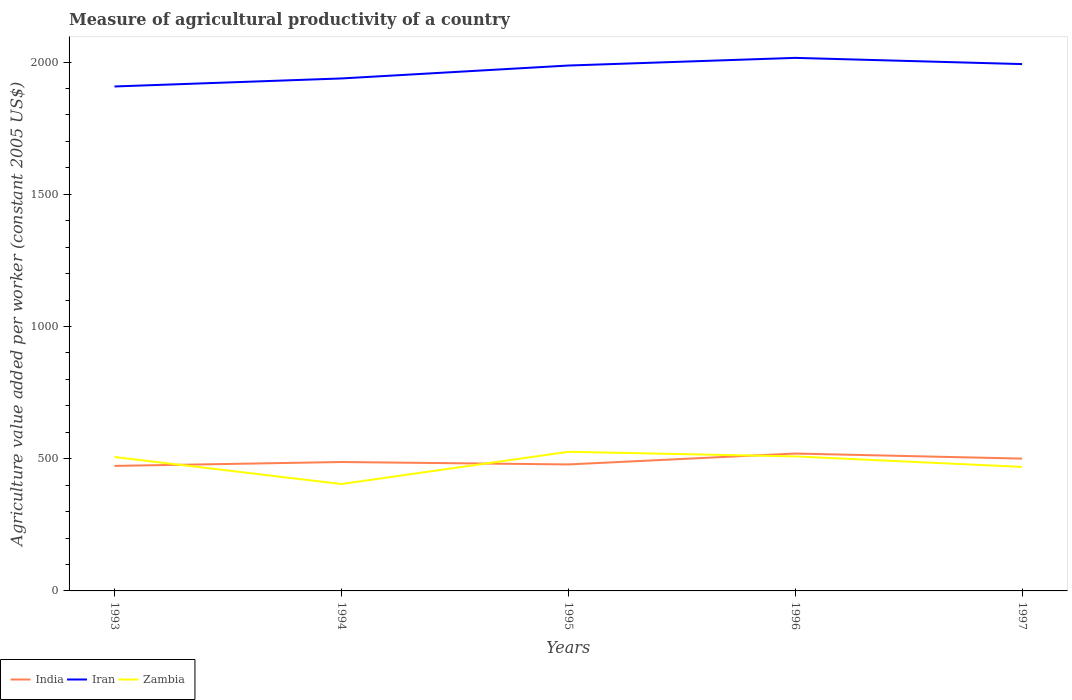Is the number of lines equal to the number of legend labels?
Offer a very short reply. Yes. Across all years, what is the maximum measure of agricultural productivity in Iran?
Offer a very short reply. 1907.84. In which year was the measure of agricultural productivity in Iran maximum?
Offer a very short reply. 1993. What is the total measure of agricultural productivity in India in the graph?
Offer a terse response. -32.1. What is the difference between the highest and the second highest measure of agricultural productivity in Iran?
Provide a succinct answer. 108.12. Is the measure of agricultural productivity in India strictly greater than the measure of agricultural productivity in Zambia over the years?
Make the answer very short. No. Where does the legend appear in the graph?
Keep it short and to the point. Bottom left. How many legend labels are there?
Offer a very short reply. 3. How are the legend labels stacked?
Keep it short and to the point. Horizontal. What is the title of the graph?
Your answer should be compact. Measure of agricultural productivity of a country. Does "Central African Republic" appear as one of the legend labels in the graph?
Your response must be concise. No. What is the label or title of the Y-axis?
Offer a terse response. Agriculture value added per worker (constant 2005 US$). What is the Agriculture value added per worker (constant 2005 US$) of India in 1993?
Your response must be concise. 472.8. What is the Agriculture value added per worker (constant 2005 US$) in Iran in 1993?
Provide a short and direct response. 1907.84. What is the Agriculture value added per worker (constant 2005 US$) in Zambia in 1993?
Keep it short and to the point. 506.52. What is the Agriculture value added per worker (constant 2005 US$) in India in 1994?
Your answer should be very brief. 487.5. What is the Agriculture value added per worker (constant 2005 US$) of Iran in 1994?
Provide a succinct answer. 1938.18. What is the Agriculture value added per worker (constant 2005 US$) of Zambia in 1994?
Ensure brevity in your answer.  404.28. What is the Agriculture value added per worker (constant 2005 US$) of India in 1995?
Provide a short and direct response. 478.37. What is the Agriculture value added per worker (constant 2005 US$) of Iran in 1995?
Your response must be concise. 1987.03. What is the Agriculture value added per worker (constant 2005 US$) in Zambia in 1995?
Your answer should be very brief. 526.2. What is the Agriculture value added per worker (constant 2005 US$) of India in 1996?
Your response must be concise. 519.6. What is the Agriculture value added per worker (constant 2005 US$) in Iran in 1996?
Offer a terse response. 2015.96. What is the Agriculture value added per worker (constant 2005 US$) of Zambia in 1996?
Your response must be concise. 508.75. What is the Agriculture value added per worker (constant 2005 US$) in India in 1997?
Your response must be concise. 500.38. What is the Agriculture value added per worker (constant 2005 US$) in Iran in 1997?
Your answer should be very brief. 1992.49. What is the Agriculture value added per worker (constant 2005 US$) in Zambia in 1997?
Your response must be concise. 469.04. Across all years, what is the maximum Agriculture value added per worker (constant 2005 US$) of India?
Your answer should be compact. 519.6. Across all years, what is the maximum Agriculture value added per worker (constant 2005 US$) in Iran?
Make the answer very short. 2015.96. Across all years, what is the maximum Agriculture value added per worker (constant 2005 US$) in Zambia?
Make the answer very short. 526.2. Across all years, what is the minimum Agriculture value added per worker (constant 2005 US$) in India?
Ensure brevity in your answer.  472.8. Across all years, what is the minimum Agriculture value added per worker (constant 2005 US$) in Iran?
Give a very brief answer. 1907.84. Across all years, what is the minimum Agriculture value added per worker (constant 2005 US$) of Zambia?
Provide a succinct answer. 404.28. What is the total Agriculture value added per worker (constant 2005 US$) in India in the graph?
Offer a terse response. 2458.64. What is the total Agriculture value added per worker (constant 2005 US$) in Iran in the graph?
Give a very brief answer. 9841.49. What is the total Agriculture value added per worker (constant 2005 US$) of Zambia in the graph?
Provide a short and direct response. 2414.79. What is the difference between the Agriculture value added per worker (constant 2005 US$) in India in 1993 and that in 1994?
Provide a short and direct response. -14.7. What is the difference between the Agriculture value added per worker (constant 2005 US$) of Iran in 1993 and that in 1994?
Make the answer very short. -30.34. What is the difference between the Agriculture value added per worker (constant 2005 US$) of Zambia in 1993 and that in 1994?
Provide a short and direct response. 102.23. What is the difference between the Agriculture value added per worker (constant 2005 US$) in India in 1993 and that in 1995?
Ensure brevity in your answer.  -5.57. What is the difference between the Agriculture value added per worker (constant 2005 US$) in Iran in 1993 and that in 1995?
Offer a terse response. -79.19. What is the difference between the Agriculture value added per worker (constant 2005 US$) in Zambia in 1993 and that in 1995?
Make the answer very short. -19.68. What is the difference between the Agriculture value added per worker (constant 2005 US$) in India in 1993 and that in 1996?
Give a very brief answer. -46.8. What is the difference between the Agriculture value added per worker (constant 2005 US$) in Iran in 1993 and that in 1996?
Your answer should be compact. -108.12. What is the difference between the Agriculture value added per worker (constant 2005 US$) of Zambia in 1993 and that in 1996?
Your answer should be very brief. -2.24. What is the difference between the Agriculture value added per worker (constant 2005 US$) in India in 1993 and that in 1997?
Keep it short and to the point. -27.58. What is the difference between the Agriculture value added per worker (constant 2005 US$) in Iran in 1993 and that in 1997?
Give a very brief answer. -84.65. What is the difference between the Agriculture value added per worker (constant 2005 US$) of Zambia in 1993 and that in 1997?
Ensure brevity in your answer.  37.48. What is the difference between the Agriculture value added per worker (constant 2005 US$) in India in 1994 and that in 1995?
Ensure brevity in your answer.  9.13. What is the difference between the Agriculture value added per worker (constant 2005 US$) in Iran in 1994 and that in 1995?
Your answer should be compact. -48.85. What is the difference between the Agriculture value added per worker (constant 2005 US$) of Zambia in 1994 and that in 1995?
Make the answer very short. -121.91. What is the difference between the Agriculture value added per worker (constant 2005 US$) of India in 1994 and that in 1996?
Your response must be concise. -32.1. What is the difference between the Agriculture value added per worker (constant 2005 US$) of Iran in 1994 and that in 1996?
Your response must be concise. -77.78. What is the difference between the Agriculture value added per worker (constant 2005 US$) in Zambia in 1994 and that in 1996?
Your answer should be very brief. -104.47. What is the difference between the Agriculture value added per worker (constant 2005 US$) of India in 1994 and that in 1997?
Provide a succinct answer. -12.88. What is the difference between the Agriculture value added per worker (constant 2005 US$) in Iran in 1994 and that in 1997?
Give a very brief answer. -54.31. What is the difference between the Agriculture value added per worker (constant 2005 US$) of Zambia in 1994 and that in 1997?
Offer a terse response. -64.76. What is the difference between the Agriculture value added per worker (constant 2005 US$) of India in 1995 and that in 1996?
Give a very brief answer. -41.23. What is the difference between the Agriculture value added per worker (constant 2005 US$) in Iran in 1995 and that in 1996?
Provide a short and direct response. -28.93. What is the difference between the Agriculture value added per worker (constant 2005 US$) of Zambia in 1995 and that in 1996?
Give a very brief answer. 17.44. What is the difference between the Agriculture value added per worker (constant 2005 US$) in India in 1995 and that in 1997?
Make the answer very short. -22.01. What is the difference between the Agriculture value added per worker (constant 2005 US$) of Iran in 1995 and that in 1997?
Your answer should be very brief. -5.46. What is the difference between the Agriculture value added per worker (constant 2005 US$) of Zambia in 1995 and that in 1997?
Keep it short and to the point. 57.15. What is the difference between the Agriculture value added per worker (constant 2005 US$) in India in 1996 and that in 1997?
Your response must be concise. 19.22. What is the difference between the Agriculture value added per worker (constant 2005 US$) of Iran in 1996 and that in 1997?
Provide a short and direct response. 23.47. What is the difference between the Agriculture value added per worker (constant 2005 US$) of Zambia in 1996 and that in 1997?
Give a very brief answer. 39.71. What is the difference between the Agriculture value added per worker (constant 2005 US$) of India in 1993 and the Agriculture value added per worker (constant 2005 US$) of Iran in 1994?
Your answer should be compact. -1465.38. What is the difference between the Agriculture value added per worker (constant 2005 US$) of India in 1993 and the Agriculture value added per worker (constant 2005 US$) of Zambia in 1994?
Your answer should be very brief. 68.51. What is the difference between the Agriculture value added per worker (constant 2005 US$) in Iran in 1993 and the Agriculture value added per worker (constant 2005 US$) in Zambia in 1994?
Make the answer very short. 1503.56. What is the difference between the Agriculture value added per worker (constant 2005 US$) of India in 1993 and the Agriculture value added per worker (constant 2005 US$) of Iran in 1995?
Provide a succinct answer. -1514.23. What is the difference between the Agriculture value added per worker (constant 2005 US$) of India in 1993 and the Agriculture value added per worker (constant 2005 US$) of Zambia in 1995?
Provide a short and direct response. -53.4. What is the difference between the Agriculture value added per worker (constant 2005 US$) in Iran in 1993 and the Agriculture value added per worker (constant 2005 US$) in Zambia in 1995?
Offer a terse response. 1381.65. What is the difference between the Agriculture value added per worker (constant 2005 US$) in India in 1993 and the Agriculture value added per worker (constant 2005 US$) in Iran in 1996?
Make the answer very short. -1543.16. What is the difference between the Agriculture value added per worker (constant 2005 US$) of India in 1993 and the Agriculture value added per worker (constant 2005 US$) of Zambia in 1996?
Provide a short and direct response. -35.96. What is the difference between the Agriculture value added per worker (constant 2005 US$) in Iran in 1993 and the Agriculture value added per worker (constant 2005 US$) in Zambia in 1996?
Ensure brevity in your answer.  1399.09. What is the difference between the Agriculture value added per worker (constant 2005 US$) of India in 1993 and the Agriculture value added per worker (constant 2005 US$) of Iran in 1997?
Your response must be concise. -1519.69. What is the difference between the Agriculture value added per worker (constant 2005 US$) of India in 1993 and the Agriculture value added per worker (constant 2005 US$) of Zambia in 1997?
Your answer should be very brief. 3.76. What is the difference between the Agriculture value added per worker (constant 2005 US$) of Iran in 1993 and the Agriculture value added per worker (constant 2005 US$) of Zambia in 1997?
Provide a succinct answer. 1438.8. What is the difference between the Agriculture value added per worker (constant 2005 US$) in India in 1994 and the Agriculture value added per worker (constant 2005 US$) in Iran in 1995?
Your answer should be compact. -1499.53. What is the difference between the Agriculture value added per worker (constant 2005 US$) in India in 1994 and the Agriculture value added per worker (constant 2005 US$) in Zambia in 1995?
Make the answer very short. -38.7. What is the difference between the Agriculture value added per worker (constant 2005 US$) of Iran in 1994 and the Agriculture value added per worker (constant 2005 US$) of Zambia in 1995?
Ensure brevity in your answer.  1411.98. What is the difference between the Agriculture value added per worker (constant 2005 US$) of India in 1994 and the Agriculture value added per worker (constant 2005 US$) of Iran in 1996?
Provide a succinct answer. -1528.46. What is the difference between the Agriculture value added per worker (constant 2005 US$) of India in 1994 and the Agriculture value added per worker (constant 2005 US$) of Zambia in 1996?
Offer a very short reply. -21.25. What is the difference between the Agriculture value added per worker (constant 2005 US$) in Iran in 1994 and the Agriculture value added per worker (constant 2005 US$) in Zambia in 1996?
Your answer should be very brief. 1429.42. What is the difference between the Agriculture value added per worker (constant 2005 US$) of India in 1994 and the Agriculture value added per worker (constant 2005 US$) of Iran in 1997?
Ensure brevity in your answer.  -1504.99. What is the difference between the Agriculture value added per worker (constant 2005 US$) of India in 1994 and the Agriculture value added per worker (constant 2005 US$) of Zambia in 1997?
Your answer should be compact. 18.46. What is the difference between the Agriculture value added per worker (constant 2005 US$) of Iran in 1994 and the Agriculture value added per worker (constant 2005 US$) of Zambia in 1997?
Ensure brevity in your answer.  1469.13. What is the difference between the Agriculture value added per worker (constant 2005 US$) in India in 1995 and the Agriculture value added per worker (constant 2005 US$) in Iran in 1996?
Offer a very short reply. -1537.59. What is the difference between the Agriculture value added per worker (constant 2005 US$) in India in 1995 and the Agriculture value added per worker (constant 2005 US$) in Zambia in 1996?
Give a very brief answer. -30.39. What is the difference between the Agriculture value added per worker (constant 2005 US$) of Iran in 1995 and the Agriculture value added per worker (constant 2005 US$) of Zambia in 1996?
Ensure brevity in your answer.  1478.27. What is the difference between the Agriculture value added per worker (constant 2005 US$) of India in 1995 and the Agriculture value added per worker (constant 2005 US$) of Iran in 1997?
Offer a very short reply. -1514.12. What is the difference between the Agriculture value added per worker (constant 2005 US$) in India in 1995 and the Agriculture value added per worker (constant 2005 US$) in Zambia in 1997?
Make the answer very short. 9.33. What is the difference between the Agriculture value added per worker (constant 2005 US$) of Iran in 1995 and the Agriculture value added per worker (constant 2005 US$) of Zambia in 1997?
Your response must be concise. 1517.99. What is the difference between the Agriculture value added per worker (constant 2005 US$) in India in 1996 and the Agriculture value added per worker (constant 2005 US$) in Iran in 1997?
Offer a very short reply. -1472.89. What is the difference between the Agriculture value added per worker (constant 2005 US$) in India in 1996 and the Agriculture value added per worker (constant 2005 US$) in Zambia in 1997?
Your response must be concise. 50.56. What is the difference between the Agriculture value added per worker (constant 2005 US$) of Iran in 1996 and the Agriculture value added per worker (constant 2005 US$) of Zambia in 1997?
Keep it short and to the point. 1546.92. What is the average Agriculture value added per worker (constant 2005 US$) in India per year?
Your response must be concise. 491.73. What is the average Agriculture value added per worker (constant 2005 US$) of Iran per year?
Offer a very short reply. 1968.3. What is the average Agriculture value added per worker (constant 2005 US$) in Zambia per year?
Provide a succinct answer. 482.96. In the year 1993, what is the difference between the Agriculture value added per worker (constant 2005 US$) in India and Agriculture value added per worker (constant 2005 US$) in Iran?
Your answer should be compact. -1435.04. In the year 1993, what is the difference between the Agriculture value added per worker (constant 2005 US$) in India and Agriculture value added per worker (constant 2005 US$) in Zambia?
Offer a terse response. -33.72. In the year 1993, what is the difference between the Agriculture value added per worker (constant 2005 US$) in Iran and Agriculture value added per worker (constant 2005 US$) in Zambia?
Keep it short and to the point. 1401.32. In the year 1994, what is the difference between the Agriculture value added per worker (constant 2005 US$) of India and Agriculture value added per worker (constant 2005 US$) of Iran?
Your answer should be very brief. -1450.68. In the year 1994, what is the difference between the Agriculture value added per worker (constant 2005 US$) of India and Agriculture value added per worker (constant 2005 US$) of Zambia?
Your response must be concise. 83.22. In the year 1994, what is the difference between the Agriculture value added per worker (constant 2005 US$) in Iran and Agriculture value added per worker (constant 2005 US$) in Zambia?
Your answer should be very brief. 1533.89. In the year 1995, what is the difference between the Agriculture value added per worker (constant 2005 US$) in India and Agriculture value added per worker (constant 2005 US$) in Iran?
Offer a terse response. -1508.66. In the year 1995, what is the difference between the Agriculture value added per worker (constant 2005 US$) of India and Agriculture value added per worker (constant 2005 US$) of Zambia?
Ensure brevity in your answer.  -47.83. In the year 1995, what is the difference between the Agriculture value added per worker (constant 2005 US$) in Iran and Agriculture value added per worker (constant 2005 US$) in Zambia?
Offer a terse response. 1460.83. In the year 1996, what is the difference between the Agriculture value added per worker (constant 2005 US$) in India and Agriculture value added per worker (constant 2005 US$) in Iran?
Your answer should be very brief. -1496.36. In the year 1996, what is the difference between the Agriculture value added per worker (constant 2005 US$) in India and Agriculture value added per worker (constant 2005 US$) in Zambia?
Ensure brevity in your answer.  10.85. In the year 1996, what is the difference between the Agriculture value added per worker (constant 2005 US$) in Iran and Agriculture value added per worker (constant 2005 US$) in Zambia?
Your answer should be compact. 1507.2. In the year 1997, what is the difference between the Agriculture value added per worker (constant 2005 US$) of India and Agriculture value added per worker (constant 2005 US$) of Iran?
Your response must be concise. -1492.11. In the year 1997, what is the difference between the Agriculture value added per worker (constant 2005 US$) in India and Agriculture value added per worker (constant 2005 US$) in Zambia?
Offer a terse response. 31.34. In the year 1997, what is the difference between the Agriculture value added per worker (constant 2005 US$) in Iran and Agriculture value added per worker (constant 2005 US$) in Zambia?
Provide a succinct answer. 1523.44. What is the ratio of the Agriculture value added per worker (constant 2005 US$) of India in 1993 to that in 1994?
Give a very brief answer. 0.97. What is the ratio of the Agriculture value added per worker (constant 2005 US$) in Iran in 1993 to that in 1994?
Offer a very short reply. 0.98. What is the ratio of the Agriculture value added per worker (constant 2005 US$) of Zambia in 1993 to that in 1994?
Provide a succinct answer. 1.25. What is the ratio of the Agriculture value added per worker (constant 2005 US$) in India in 1993 to that in 1995?
Ensure brevity in your answer.  0.99. What is the ratio of the Agriculture value added per worker (constant 2005 US$) in Iran in 1993 to that in 1995?
Ensure brevity in your answer.  0.96. What is the ratio of the Agriculture value added per worker (constant 2005 US$) in Zambia in 1993 to that in 1995?
Make the answer very short. 0.96. What is the ratio of the Agriculture value added per worker (constant 2005 US$) of India in 1993 to that in 1996?
Offer a very short reply. 0.91. What is the ratio of the Agriculture value added per worker (constant 2005 US$) of Iran in 1993 to that in 1996?
Keep it short and to the point. 0.95. What is the ratio of the Agriculture value added per worker (constant 2005 US$) of Zambia in 1993 to that in 1996?
Give a very brief answer. 1. What is the ratio of the Agriculture value added per worker (constant 2005 US$) in India in 1993 to that in 1997?
Your response must be concise. 0.94. What is the ratio of the Agriculture value added per worker (constant 2005 US$) of Iran in 1993 to that in 1997?
Provide a short and direct response. 0.96. What is the ratio of the Agriculture value added per worker (constant 2005 US$) in Zambia in 1993 to that in 1997?
Offer a very short reply. 1.08. What is the ratio of the Agriculture value added per worker (constant 2005 US$) in India in 1994 to that in 1995?
Your answer should be very brief. 1.02. What is the ratio of the Agriculture value added per worker (constant 2005 US$) of Iran in 1994 to that in 1995?
Offer a very short reply. 0.98. What is the ratio of the Agriculture value added per worker (constant 2005 US$) of Zambia in 1994 to that in 1995?
Your answer should be very brief. 0.77. What is the ratio of the Agriculture value added per worker (constant 2005 US$) in India in 1994 to that in 1996?
Keep it short and to the point. 0.94. What is the ratio of the Agriculture value added per worker (constant 2005 US$) of Iran in 1994 to that in 1996?
Provide a short and direct response. 0.96. What is the ratio of the Agriculture value added per worker (constant 2005 US$) of Zambia in 1994 to that in 1996?
Ensure brevity in your answer.  0.79. What is the ratio of the Agriculture value added per worker (constant 2005 US$) in India in 1994 to that in 1997?
Give a very brief answer. 0.97. What is the ratio of the Agriculture value added per worker (constant 2005 US$) in Iran in 1994 to that in 1997?
Your answer should be compact. 0.97. What is the ratio of the Agriculture value added per worker (constant 2005 US$) in Zambia in 1994 to that in 1997?
Your response must be concise. 0.86. What is the ratio of the Agriculture value added per worker (constant 2005 US$) of India in 1995 to that in 1996?
Make the answer very short. 0.92. What is the ratio of the Agriculture value added per worker (constant 2005 US$) in Iran in 1995 to that in 1996?
Make the answer very short. 0.99. What is the ratio of the Agriculture value added per worker (constant 2005 US$) of Zambia in 1995 to that in 1996?
Your response must be concise. 1.03. What is the ratio of the Agriculture value added per worker (constant 2005 US$) in India in 1995 to that in 1997?
Your response must be concise. 0.96. What is the ratio of the Agriculture value added per worker (constant 2005 US$) in Iran in 1995 to that in 1997?
Keep it short and to the point. 1. What is the ratio of the Agriculture value added per worker (constant 2005 US$) of Zambia in 1995 to that in 1997?
Your answer should be compact. 1.12. What is the ratio of the Agriculture value added per worker (constant 2005 US$) of India in 1996 to that in 1997?
Offer a terse response. 1.04. What is the ratio of the Agriculture value added per worker (constant 2005 US$) in Iran in 1996 to that in 1997?
Make the answer very short. 1.01. What is the ratio of the Agriculture value added per worker (constant 2005 US$) in Zambia in 1996 to that in 1997?
Give a very brief answer. 1.08. What is the difference between the highest and the second highest Agriculture value added per worker (constant 2005 US$) in India?
Make the answer very short. 19.22. What is the difference between the highest and the second highest Agriculture value added per worker (constant 2005 US$) of Iran?
Give a very brief answer. 23.47. What is the difference between the highest and the second highest Agriculture value added per worker (constant 2005 US$) in Zambia?
Provide a short and direct response. 17.44. What is the difference between the highest and the lowest Agriculture value added per worker (constant 2005 US$) of India?
Your response must be concise. 46.8. What is the difference between the highest and the lowest Agriculture value added per worker (constant 2005 US$) in Iran?
Your answer should be compact. 108.12. What is the difference between the highest and the lowest Agriculture value added per worker (constant 2005 US$) of Zambia?
Your answer should be compact. 121.91. 